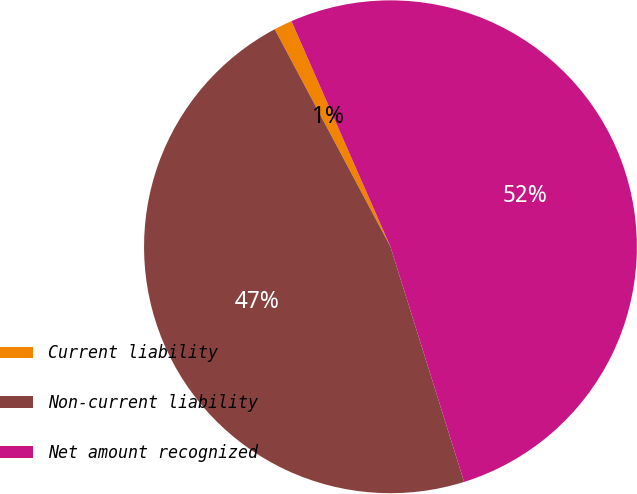Convert chart. <chart><loc_0><loc_0><loc_500><loc_500><pie_chart><fcel>Current liability<fcel>Non-current liability<fcel>Net amount recognized<nl><fcel>1.2%<fcel>47.05%<fcel>51.75%<nl></chart> 